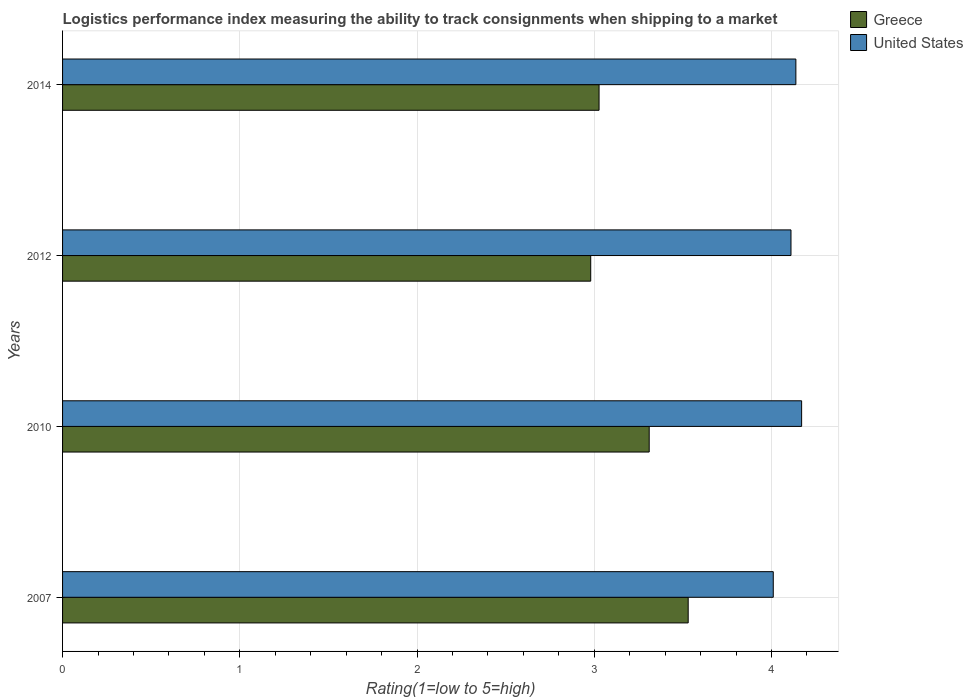How many different coloured bars are there?
Provide a short and direct response. 2. How many groups of bars are there?
Your answer should be compact. 4. Are the number of bars per tick equal to the number of legend labels?
Give a very brief answer. Yes. Are the number of bars on each tick of the Y-axis equal?
Make the answer very short. Yes. How many bars are there on the 3rd tick from the top?
Ensure brevity in your answer.  2. How many bars are there on the 2nd tick from the bottom?
Provide a succinct answer. 2. What is the label of the 2nd group of bars from the top?
Provide a succinct answer. 2012. What is the Logistic performance index in United States in 2010?
Provide a short and direct response. 4.17. Across all years, what is the maximum Logistic performance index in Greece?
Keep it short and to the point. 3.53. Across all years, what is the minimum Logistic performance index in Greece?
Give a very brief answer. 2.98. In which year was the Logistic performance index in United States minimum?
Your response must be concise. 2007. What is the total Logistic performance index in United States in the graph?
Keep it short and to the point. 16.43. What is the difference between the Logistic performance index in United States in 2010 and that in 2012?
Provide a short and direct response. 0.06. What is the difference between the Logistic performance index in Greece in 2007 and the Logistic performance index in United States in 2012?
Offer a terse response. -0.58. What is the average Logistic performance index in United States per year?
Your response must be concise. 4.11. In the year 2010, what is the difference between the Logistic performance index in United States and Logistic performance index in Greece?
Ensure brevity in your answer.  0.86. What is the ratio of the Logistic performance index in Greece in 2007 to that in 2012?
Your answer should be compact. 1.18. Is the Logistic performance index in Greece in 2012 less than that in 2014?
Your answer should be very brief. Yes. What is the difference between the highest and the second highest Logistic performance index in Greece?
Provide a succinct answer. 0.22. What is the difference between the highest and the lowest Logistic performance index in United States?
Your response must be concise. 0.16. In how many years, is the Logistic performance index in Greece greater than the average Logistic performance index in Greece taken over all years?
Your answer should be compact. 2. What does the 2nd bar from the bottom in 2012 represents?
Give a very brief answer. United States. How many years are there in the graph?
Provide a succinct answer. 4. What is the difference between two consecutive major ticks on the X-axis?
Give a very brief answer. 1. How many legend labels are there?
Provide a succinct answer. 2. How are the legend labels stacked?
Offer a terse response. Vertical. What is the title of the graph?
Your answer should be very brief. Logistics performance index measuring the ability to track consignments when shipping to a market. Does "Middle income" appear as one of the legend labels in the graph?
Your response must be concise. No. What is the label or title of the X-axis?
Provide a short and direct response. Rating(1=low to 5=high). What is the Rating(1=low to 5=high) in Greece in 2007?
Provide a succinct answer. 3.53. What is the Rating(1=low to 5=high) in United States in 2007?
Offer a terse response. 4.01. What is the Rating(1=low to 5=high) in Greece in 2010?
Your answer should be very brief. 3.31. What is the Rating(1=low to 5=high) of United States in 2010?
Offer a very short reply. 4.17. What is the Rating(1=low to 5=high) of Greece in 2012?
Provide a short and direct response. 2.98. What is the Rating(1=low to 5=high) in United States in 2012?
Keep it short and to the point. 4.11. What is the Rating(1=low to 5=high) of Greece in 2014?
Ensure brevity in your answer.  3.03. What is the Rating(1=low to 5=high) of United States in 2014?
Provide a succinct answer. 4.14. Across all years, what is the maximum Rating(1=low to 5=high) in Greece?
Provide a succinct answer. 3.53. Across all years, what is the maximum Rating(1=low to 5=high) of United States?
Provide a short and direct response. 4.17. Across all years, what is the minimum Rating(1=low to 5=high) in Greece?
Offer a very short reply. 2.98. Across all years, what is the minimum Rating(1=low to 5=high) of United States?
Provide a short and direct response. 4.01. What is the total Rating(1=low to 5=high) of Greece in the graph?
Give a very brief answer. 12.85. What is the total Rating(1=low to 5=high) of United States in the graph?
Your answer should be compact. 16.43. What is the difference between the Rating(1=low to 5=high) of Greece in 2007 and that in 2010?
Your response must be concise. 0.22. What is the difference between the Rating(1=low to 5=high) of United States in 2007 and that in 2010?
Offer a terse response. -0.16. What is the difference between the Rating(1=low to 5=high) in Greece in 2007 and that in 2012?
Offer a terse response. 0.55. What is the difference between the Rating(1=low to 5=high) in United States in 2007 and that in 2012?
Provide a short and direct response. -0.1. What is the difference between the Rating(1=low to 5=high) in Greece in 2007 and that in 2014?
Provide a short and direct response. 0.5. What is the difference between the Rating(1=low to 5=high) of United States in 2007 and that in 2014?
Ensure brevity in your answer.  -0.13. What is the difference between the Rating(1=low to 5=high) of Greece in 2010 and that in 2012?
Offer a terse response. 0.33. What is the difference between the Rating(1=low to 5=high) in United States in 2010 and that in 2012?
Ensure brevity in your answer.  0.06. What is the difference between the Rating(1=low to 5=high) of Greece in 2010 and that in 2014?
Give a very brief answer. 0.28. What is the difference between the Rating(1=low to 5=high) in United States in 2010 and that in 2014?
Offer a terse response. 0.03. What is the difference between the Rating(1=low to 5=high) of Greece in 2012 and that in 2014?
Offer a very short reply. -0.05. What is the difference between the Rating(1=low to 5=high) of United States in 2012 and that in 2014?
Offer a very short reply. -0.03. What is the difference between the Rating(1=low to 5=high) in Greece in 2007 and the Rating(1=low to 5=high) in United States in 2010?
Offer a terse response. -0.64. What is the difference between the Rating(1=low to 5=high) in Greece in 2007 and the Rating(1=low to 5=high) in United States in 2012?
Provide a succinct answer. -0.58. What is the difference between the Rating(1=low to 5=high) in Greece in 2007 and the Rating(1=low to 5=high) in United States in 2014?
Make the answer very short. -0.61. What is the difference between the Rating(1=low to 5=high) in Greece in 2010 and the Rating(1=low to 5=high) in United States in 2012?
Your answer should be very brief. -0.8. What is the difference between the Rating(1=low to 5=high) in Greece in 2010 and the Rating(1=low to 5=high) in United States in 2014?
Provide a short and direct response. -0.83. What is the difference between the Rating(1=low to 5=high) of Greece in 2012 and the Rating(1=low to 5=high) of United States in 2014?
Keep it short and to the point. -1.16. What is the average Rating(1=low to 5=high) in Greece per year?
Provide a succinct answer. 3.21. What is the average Rating(1=low to 5=high) in United States per year?
Provide a succinct answer. 4.11. In the year 2007, what is the difference between the Rating(1=low to 5=high) of Greece and Rating(1=low to 5=high) of United States?
Keep it short and to the point. -0.48. In the year 2010, what is the difference between the Rating(1=low to 5=high) of Greece and Rating(1=low to 5=high) of United States?
Your answer should be very brief. -0.86. In the year 2012, what is the difference between the Rating(1=low to 5=high) in Greece and Rating(1=low to 5=high) in United States?
Give a very brief answer. -1.13. In the year 2014, what is the difference between the Rating(1=low to 5=high) of Greece and Rating(1=low to 5=high) of United States?
Keep it short and to the point. -1.11. What is the ratio of the Rating(1=low to 5=high) of Greece in 2007 to that in 2010?
Give a very brief answer. 1.07. What is the ratio of the Rating(1=low to 5=high) of United States in 2007 to that in 2010?
Your response must be concise. 0.96. What is the ratio of the Rating(1=low to 5=high) of Greece in 2007 to that in 2012?
Give a very brief answer. 1.18. What is the ratio of the Rating(1=low to 5=high) in United States in 2007 to that in 2012?
Your answer should be compact. 0.98. What is the ratio of the Rating(1=low to 5=high) in Greece in 2007 to that in 2014?
Provide a succinct answer. 1.17. What is the ratio of the Rating(1=low to 5=high) in United States in 2007 to that in 2014?
Make the answer very short. 0.97. What is the ratio of the Rating(1=low to 5=high) of Greece in 2010 to that in 2012?
Your answer should be very brief. 1.11. What is the ratio of the Rating(1=low to 5=high) of United States in 2010 to that in 2012?
Your answer should be compact. 1.01. What is the ratio of the Rating(1=low to 5=high) of Greece in 2010 to that in 2014?
Your response must be concise. 1.09. What is the ratio of the Rating(1=low to 5=high) in United States in 2010 to that in 2014?
Offer a very short reply. 1.01. What is the ratio of the Rating(1=low to 5=high) in Greece in 2012 to that in 2014?
Provide a short and direct response. 0.98. What is the ratio of the Rating(1=low to 5=high) in United States in 2012 to that in 2014?
Provide a succinct answer. 0.99. What is the difference between the highest and the second highest Rating(1=low to 5=high) in Greece?
Provide a short and direct response. 0.22. What is the difference between the highest and the second highest Rating(1=low to 5=high) in United States?
Your answer should be very brief. 0.03. What is the difference between the highest and the lowest Rating(1=low to 5=high) of Greece?
Offer a terse response. 0.55. What is the difference between the highest and the lowest Rating(1=low to 5=high) in United States?
Provide a succinct answer. 0.16. 